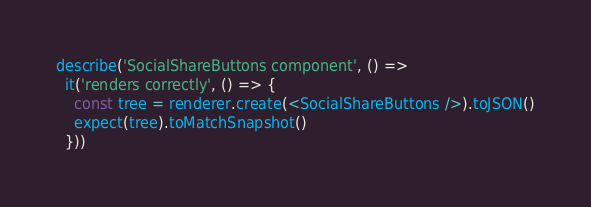<code> <loc_0><loc_0><loc_500><loc_500><_TypeScript_>
describe('SocialShareButtons component', () =>
  it('renders correctly', () => {
    const tree = renderer.create(<SocialShareButtons />).toJSON()
    expect(tree).toMatchSnapshot()
  }))
</code> 